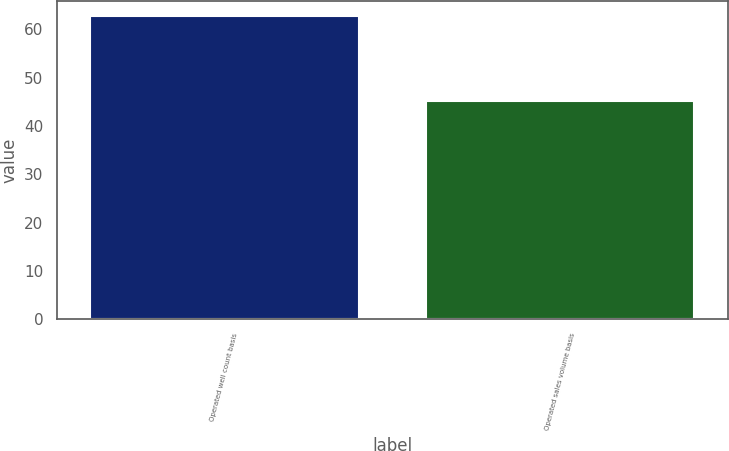<chart> <loc_0><loc_0><loc_500><loc_500><bar_chart><fcel>Operated well count basis<fcel>Operated sales volume basis<nl><fcel>62.8<fcel>45.1<nl></chart> 